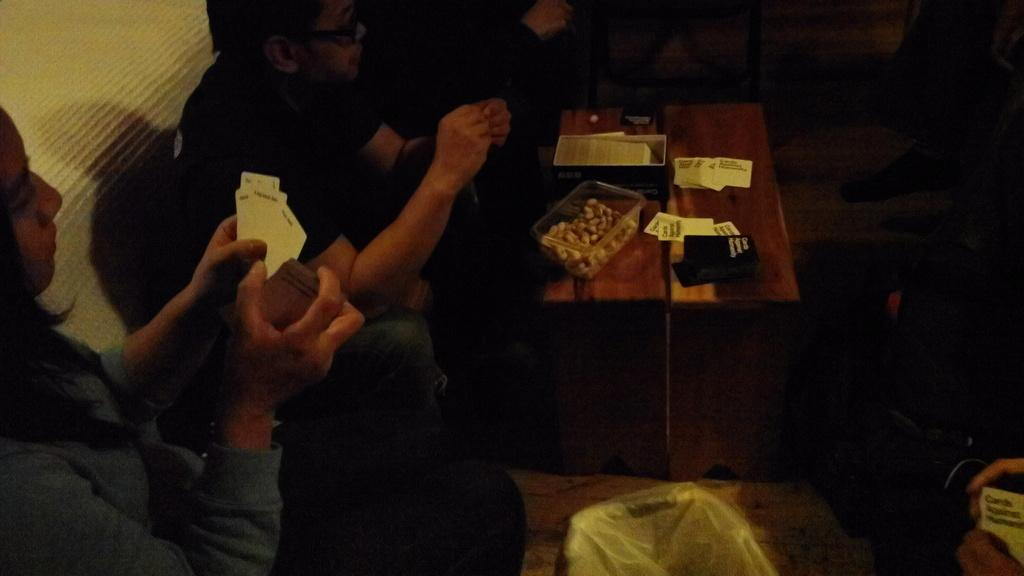How many people are in the image? There are people in the image, but the exact number is not specified. What is one person doing with their hands? One person is holding cards. What objects are on the table in the image? There are boxes and cards on the table. How do the fairies in the image increase the level of comfort for the people? There are no fairies present in the image, so they cannot increase the level of comfort for the people. 